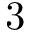Convert formula to latex. <formula><loc_0><loc_0><loc_500><loc_500>3</formula> 